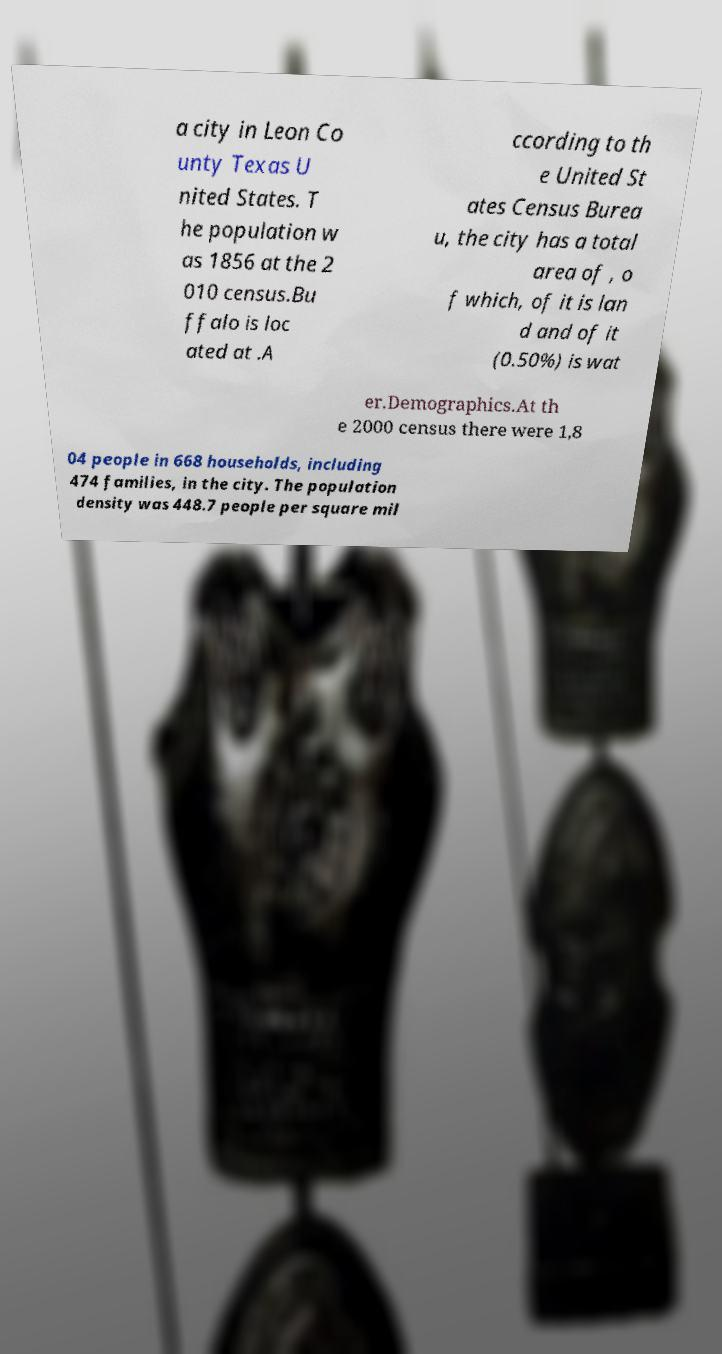Please read and relay the text visible in this image. What does it say? a city in Leon Co unty Texas U nited States. T he population w as 1856 at the 2 010 census.Bu ffalo is loc ated at .A ccording to th e United St ates Census Burea u, the city has a total area of , o f which, of it is lan d and of it (0.50%) is wat er.Demographics.At th e 2000 census there were 1,8 04 people in 668 households, including 474 families, in the city. The population density was 448.7 people per square mil 